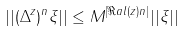Convert formula to latex. <formula><loc_0><loc_0><loc_500><loc_500>| | ( \Delta ^ { z } ) ^ { n } \xi | | \leq M ^ { | \Re a l ( z ) n | } | | \xi | |</formula> 